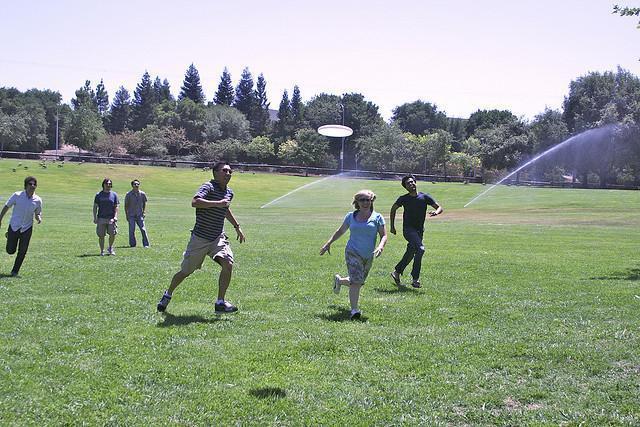How many people are in the picture?
Give a very brief answer. 6. How many adults are standing?
Give a very brief answer. 6. How many people are there?
Give a very brief answer. 4. 